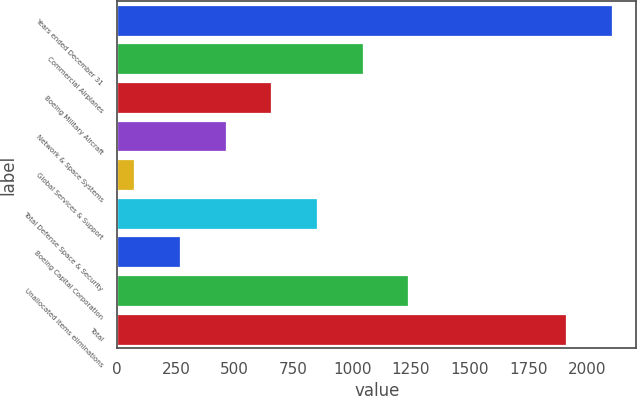Convert chart. <chart><loc_0><loc_0><loc_500><loc_500><bar_chart><fcel>Years ended December 31<fcel>Commercial Airplanes<fcel>Boeing Military Aircraft<fcel>Network & Space Systems<fcel>Global Services & Support<fcel>Total Defense Space & Security<fcel>Boeing Capital Corporation<fcel>Unallocated items eliminations<fcel>Total<nl><fcel>2104.3<fcel>1044.5<fcel>655.9<fcel>461.6<fcel>73<fcel>850.2<fcel>267.3<fcel>1238.8<fcel>1910<nl></chart> 